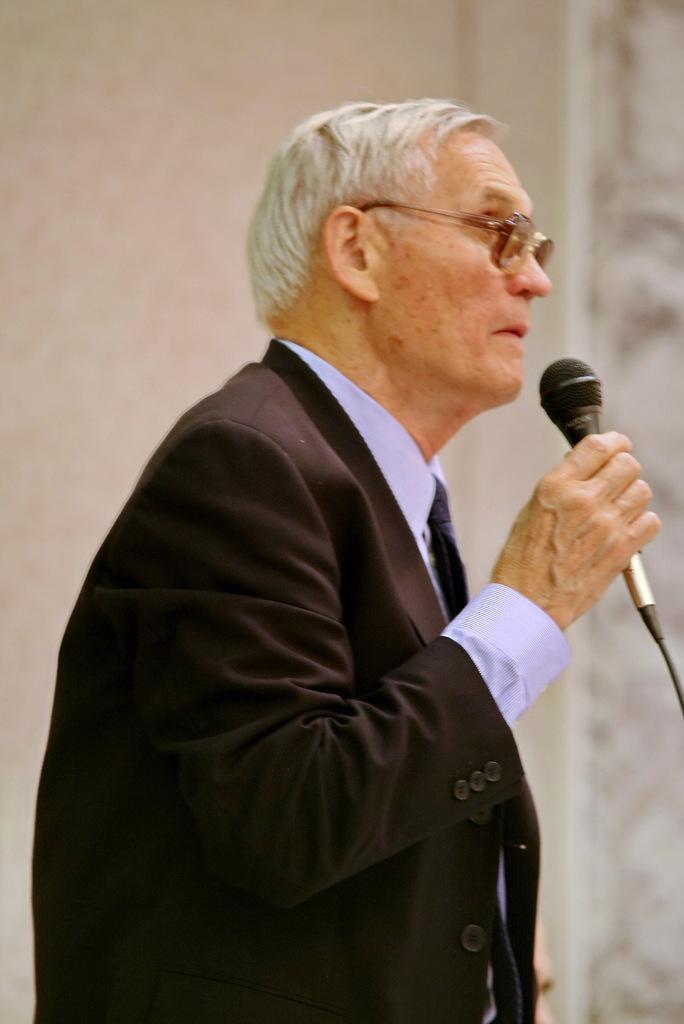In one or two sentences, can you explain what this image depicts? Here we see a man standing and holding a microphone in his hand. 